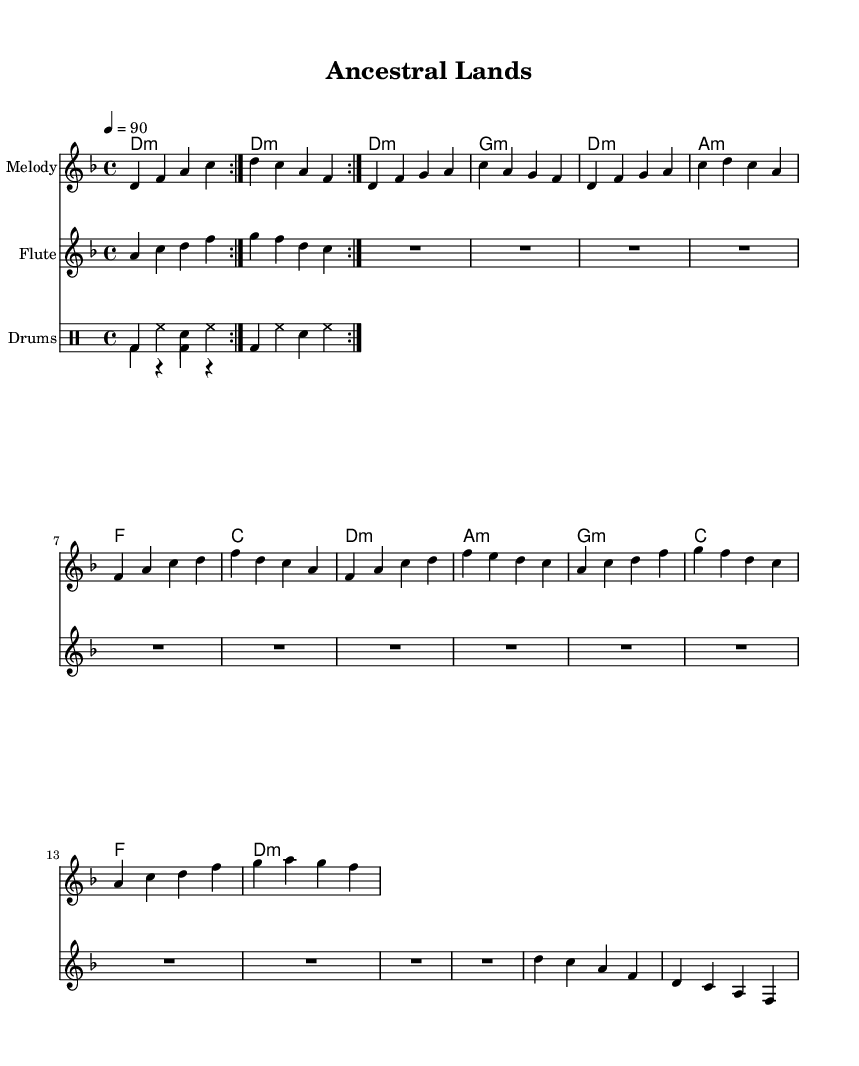What is the key signature of this music? The key signature is indicated at the beginning of the staff and shows two flats, which corresponds to the key of D minor.
Answer: D minor What is the time signature of this music? The time signature is found at the start of the staff and is represented by 4/4, indicating four beats per measure.
Answer: 4/4 What is the tempo marking of this piece? The tempo marking shows a quarter note equal to 90 beats per minute, indicating the speed of the music.
Answer: 90 How many measures are in the chorus section? By reviewing the written measures in the chorus, we see there are four measures specifically designated for this part of the music.
Answer: 4 What instruments are featured in this score? The instruments are listed at the beginning of their respective staves, showing that the score includes Melody, Flute, and Drums.
Answer: Melody, Flute, Drums What rhythmic element is predominant in the indigenous drum part? The indigenous drum part exhibits a rhythmic pattern of bass drum followed by rests, creating a traditional beat typical of indigenous music.
Answer: Bass drum and rests What thematic elements does this piece likely explore based on its title? The title “Ancestral Lands” suggests themes related to land preservation and cultural heritage, likely connected to Indigenous perspectives.
Answer: Land preservation, cultural heritage 